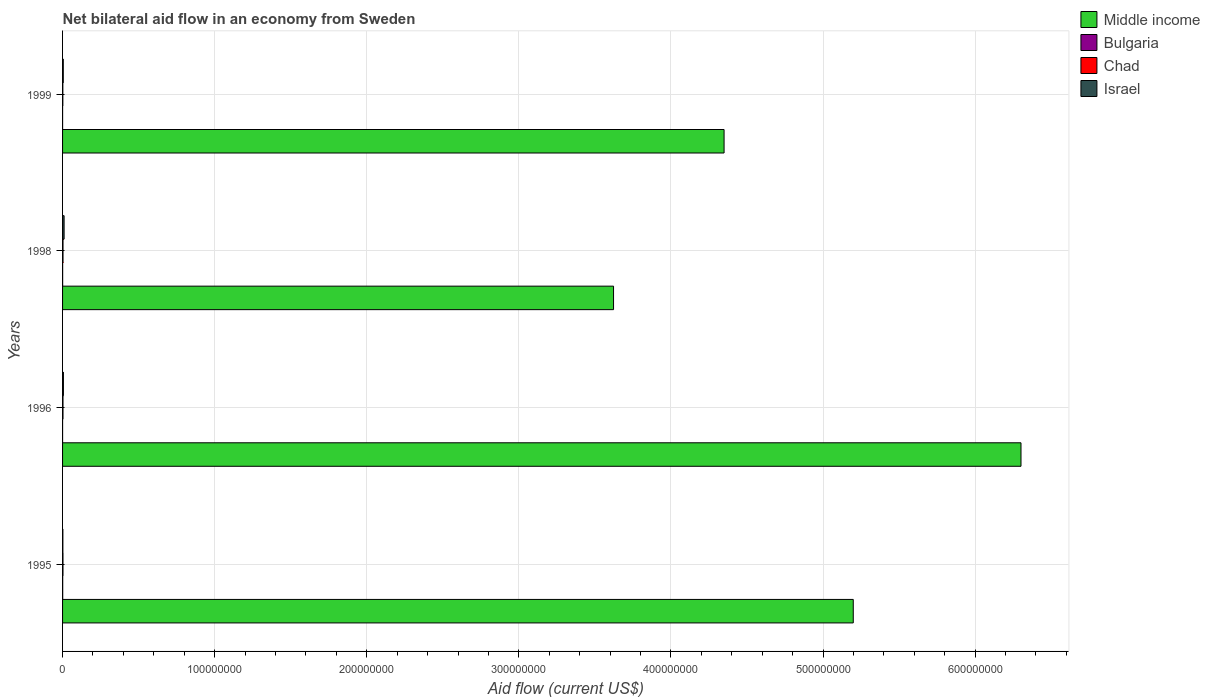How many different coloured bars are there?
Provide a short and direct response. 4. How many groups of bars are there?
Offer a terse response. 4. Are the number of bars per tick equal to the number of legend labels?
Your response must be concise. Yes. How many bars are there on the 3rd tick from the top?
Offer a terse response. 4. How many bars are there on the 3rd tick from the bottom?
Make the answer very short. 4. What is the label of the 4th group of bars from the top?
Your answer should be compact. 1995. What is the net bilateral aid flow in Chad in 1999?
Give a very brief answer. 1.80e+05. Across all years, what is the maximum net bilateral aid flow in Middle income?
Ensure brevity in your answer.  6.30e+08. In which year was the net bilateral aid flow in Middle income maximum?
Your answer should be compact. 1996. What is the total net bilateral aid flow in Chad in the graph?
Ensure brevity in your answer.  1.04e+06. What is the difference between the net bilateral aid flow in Middle income in 1995 and that in 1999?
Give a very brief answer. 8.49e+07. What is the difference between the net bilateral aid flow in Middle income in 1996 and the net bilateral aid flow in Israel in 1998?
Ensure brevity in your answer.  6.29e+08. What is the average net bilateral aid flow in Israel per year?
Make the answer very short. 5.60e+05. In how many years, is the net bilateral aid flow in Middle income greater than 100000000 US$?
Give a very brief answer. 4. What is the ratio of the net bilateral aid flow in Chad in 1996 to that in 1999?
Provide a short and direct response. 1.61. Is the net bilateral aid flow in Bulgaria in 1995 less than that in 1999?
Keep it short and to the point. No. In how many years, is the net bilateral aid flow in Bulgaria greater than the average net bilateral aid flow in Bulgaria taken over all years?
Give a very brief answer. 2. Is the sum of the net bilateral aid flow in Chad in 1995 and 1998 greater than the maximum net bilateral aid flow in Middle income across all years?
Your response must be concise. No. Is it the case that in every year, the sum of the net bilateral aid flow in Bulgaria and net bilateral aid flow in Israel is greater than the sum of net bilateral aid flow in Chad and net bilateral aid flow in Middle income?
Ensure brevity in your answer.  No. What does the 3rd bar from the bottom in 1995 represents?
Your response must be concise. Chad. How many bars are there?
Your answer should be very brief. 16. Are all the bars in the graph horizontal?
Your answer should be very brief. Yes. How many years are there in the graph?
Give a very brief answer. 4. What is the difference between two consecutive major ticks on the X-axis?
Keep it short and to the point. 1.00e+08. Does the graph contain any zero values?
Your answer should be compact. No. Does the graph contain grids?
Provide a succinct answer. Yes. Where does the legend appear in the graph?
Give a very brief answer. Top right. What is the title of the graph?
Give a very brief answer. Net bilateral aid flow in an economy from Sweden. Does "Yemen, Rep." appear as one of the legend labels in the graph?
Provide a succinct answer. No. What is the label or title of the Y-axis?
Provide a short and direct response. Years. What is the Aid flow (current US$) in Middle income in 1995?
Offer a terse response. 5.20e+08. What is the Aid flow (current US$) in Chad in 1995?
Offer a terse response. 2.70e+05. What is the Aid flow (current US$) in Israel in 1995?
Keep it short and to the point. 2.00e+05. What is the Aid flow (current US$) of Middle income in 1996?
Your answer should be compact. 6.30e+08. What is the Aid flow (current US$) of Bulgaria in 1996?
Your answer should be compact. 10000. What is the Aid flow (current US$) in Israel in 1996?
Keep it short and to the point. 5.60e+05. What is the Aid flow (current US$) of Middle income in 1998?
Provide a succinct answer. 3.62e+08. What is the Aid flow (current US$) in Chad in 1998?
Your response must be concise. 3.00e+05. What is the Aid flow (current US$) of Israel in 1998?
Your answer should be compact. 1.01e+06. What is the Aid flow (current US$) of Middle income in 1999?
Your answer should be compact. 4.35e+08. What is the Aid flow (current US$) of Israel in 1999?
Offer a terse response. 4.70e+05. Across all years, what is the maximum Aid flow (current US$) of Middle income?
Your response must be concise. 6.30e+08. Across all years, what is the maximum Aid flow (current US$) in Israel?
Ensure brevity in your answer.  1.01e+06. Across all years, what is the minimum Aid flow (current US$) of Middle income?
Provide a short and direct response. 3.62e+08. Across all years, what is the minimum Aid flow (current US$) in Chad?
Make the answer very short. 1.80e+05. What is the total Aid flow (current US$) in Middle income in the graph?
Provide a short and direct response. 1.95e+09. What is the total Aid flow (current US$) in Chad in the graph?
Offer a terse response. 1.04e+06. What is the total Aid flow (current US$) in Israel in the graph?
Offer a terse response. 2.24e+06. What is the difference between the Aid flow (current US$) in Middle income in 1995 and that in 1996?
Give a very brief answer. -1.10e+08. What is the difference between the Aid flow (current US$) in Israel in 1995 and that in 1996?
Provide a short and direct response. -3.60e+05. What is the difference between the Aid flow (current US$) of Middle income in 1995 and that in 1998?
Your response must be concise. 1.58e+08. What is the difference between the Aid flow (current US$) of Chad in 1995 and that in 1998?
Offer a terse response. -3.00e+04. What is the difference between the Aid flow (current US$) in Israel in 1995 and that in 1998?
Your answer should be very brief. -8.10e+05. What is the difference between the Aid flow (current US$) of Middle income in 1995 and that in 1999?
Your answer should be compact. 8.49e+07. What is the difference between the Aid flow (current US$) in Bulgaria in 1995 and that in 1999?
Offer a very short reply. 7.00e+04. What is the difference between the Aid flow (current US$) in Chad in 1995 and that in 1999?
Your response must be concise. 9.00e+04. What is the difference between the Aid flow (current US$) of Middle income in 1996 and that in 1998?
Your answer should be compact. 2.68e+08. What is the difference between the Aid flow (current US$) of Bulgaria in 1996 and that in 1998?
Make the answer very short. -4.00e+04. What is the difference between the Aid flow (current US$) of Chad in 1996 and that in 1998?
Make the answer very short. -10000. What is the difference between the Aid flow (current US$) in Israel in 1996 and that in 1998?
Ensure brevity in your answer.  -4.50e+05. What is the difference between the Aid flow (current US$) in Middle income in 1996 and that in 1999?
Provide a short and direct response. 1.95e+08. What is the difference between the Aid flow (current US$) in Bulgaria in 1996 and that in 1999?
Provide a short and direct response. -10000. What is the difference between the Aid flow (current US$) of Chad in 1996 and that in 1999?
Keep it short and to the point. 1.10e+05. What is the difference between the Aid flow (current US$) of Israel in 1996 and that in 1999?
Offer a terse response. 9.00e+04. What is the difference between the Aid flow (current US$) of Middle income in 1998 and that in 1999?
Give a very brief answer. -7.27e+07. What is the difference between the Aid flow (current US$) of Chad in 1998 and that in 1999?
Give a very brief answer. 1.20e+05. What is the difference between the Aid flow (current US$) in Israel in 1998 and that in 1999?
Keep it short and to the point. 5.40e+05. What is the difference between the Aid flow (current US$) in Middle income in 1995 and the Aid flow (current US$) in Bulgaria in 1996?
Your response must be concise. 5.20e+08. What is the difference between the Aid flow (current US$) of Middle income in 1995 and the Aid flow (current US$) of Chad in 1996?
Offer a terse response. 5.20e+08. What is the difference between the Aid flow (current US$) of Middle income in 1995 and the Aid flow (current US$) of Israel in 1996?
Give a very brief answer. 5.19e+08. What is the difference between the Aid flow (current US$) of Bulgaria in 1995 and the Aid flow (current US$) of Israel in 1996?
Provide a short and direct response. -4.70e+05. What is the difference between the Aid flow (current US$) of Chad in 1995 and the Aid flow (current US$) of Israel in 1996?
Make the answer very short. -2.90e+05. What is the difference between the Aid flow (current US$) in Middle income in 1995 and the Aid flow (current US$) in Bulgaria in 1998?
Your answer should be very brief. 5.20e+08. What is the difference between the Aid flow (current US$) of Middle income in 1995 and the Aid flow (current US$) of Chad in 1998?
Keep it short and to the point. 5.20e+08. What is the difference between the Aid flow (current US$) in Middle income in 1995 and the Aid flow (current US$) in Israel in 1998?
Offer a terse response. 5.19e+08. What is the difference between the Aid flow (current US$) of Bulgaria in 1995 and the Aid flow (current US$) of Israel in 1998?
Offer a very short reply. -9.20e+05. What is the difference between the Aid flow (current US$) in Chad in 1995 and the Aid flow (current US$) in Israel in 1998?
Keep it short and to the point. -7.40e+05. What is the difference between the Aid flow (current US$) in Middle income in 1995 and the Aid flow (current US$) in Bulgaria in 1999?
Your response must be concise. 5.20e+08. What is the difference between the Aid flow (current US$) of Middle income in 1995 and the Aid flow (current US$) of Chad in 1999?
Offer a very short reply. 5.20e+08. What is the difference between the Aid flow (current US$) in Middle income in 1995 and the Aid flow (current US$) in Israel in 1999?
Your response must be concise. 5.19e+08. What is the difference between the Aid flow (current US$) in Bulgaria in 1995 and the Aid flow (current US$) in Israel in 1999?
Ensure brevity in your answer.  -3.80e+05. What is the difference between the Aid flow (current US$) in Middle income in 1996 and the Aid flow (current US$) in Bulgaria in 1998?
Make the answer very short. 6.30e+08. What is the difference between the Aid flow (current US$) in Middle income in 1996 and the Aid flow (current US$) in Chad in 1998?
Your answer should be very brief. 6.30e+08. What is the difference between the Aid flow (current US$) of Middle income in 1996 and the Aid flow (current US$) of Israel in 1998?
Ensure brevity in your answer.  6.29e+08. What is the difference between the Aid flow (current US$) of Bulgaria in 1996 and the Aid flow (current US$) of Chad in 1998?
Provide a succinct answer. -2.90e+05. What is the difference between the Aid flow (current US$) in Chad in 1996 and the Aid flow (current US$) in Israel in 1998?
Give a very brief answer. -7.20e+05. What is the difference between the Aid flow (current US$) of Middle income in 1996 and the Aid flow (current US$) of Bulgaria in 1999?
Your answer should be very brief. 6.30e+08. What is the difference between the Aid flow (current US$) of Middle income in 1996 and the Aid flow (current US$) of Chad in 1999?
Give a very brief answer. 6.30e+08. What is the difference between the Aid flow (current US$) in Middle income in 1996 and the Aid flow (current US$) in Israel in 1999?
Offer a very short reply. 6.30e+08. What is the difference between the Aid flow (current US$) in Bulgaria in 1996 and the Aid flow (current US$) in Chad in 1999?
Your answer should be very brief. -1.70e+05. What is the difference between the Aid flow (current US$) in Bulgaria in 1996 and the Aid flow (current US$) in Israel in 1999?
Ensure brevity in your answer.  -4.60e+05. What is the difference between the Aid flow (current US$) in Middle income in 1998 and the Aid flow (current US$) in Bulgaria in 1999?
Provide a succinct answer. 3.62e+08. What is the difference between the Aid flow (current US$) in Middle income in 1998 and the Aid flow (current US$) in Chad in 1999?
Provide a succinct answer. 3.62e+08. What is the difference between the Aid flow (current US$) in Middle income in 1998 and the Aid flow (current US$) in Israel in 1999?
Your answer should be very brief. 3.62e+08. What is the difference between the Aid flow (current US$) in Bulgaria in 1998 and the Aid flow (current US$) in Chad in 1999?
Offer a very short reply. -1.30e+05. What is the difference between the Aid flow (current US$) in Bulgaria in 1998 and the Aid flow (current US$) in Israel in 1999?
Your answer should be compact. -4.20e+05. What is the average Aid flow (current US$) of Middle income per year?
Ensure brevity in your answer.  4.87e+08. What is the average Aid flow (current US$) of Bulgaria per year?
Offer a very short reply. 4.25e+04. What is the average Aid flow (current US$) of Chad per year?
Offer a very short reply. 2.60e+05. What is the average Aid flow (current US$) in Israel per year?
Keep it short and to the point. 5.60e+05. In the year 1995, what is the difference between the Aid flow (current US$) of Middle income and Aid flow (current US$) of Bulgaria?
Ensure brevity in your answer.  5.20e+08. In the year 1995, what is the difference between the Aid flow (current US$) in Middle income and Aid flow (current US$) in Chad?
Your answer should be compact. 5.20e+08. In the year 1995, what is the difference between the Aid flow (current US$) in Middle income and Aid flow (current US$) in Israel?
Provide a short and direct response. 5.20e+08. In the year 1995, what is the difference between the Aid flow (current US$) in Bulgaria and Aid flow (current US$) in Chad?
Your answer should be compact. -1.80e+05. In the year 1995, what is the difference between the Aid flow (current US$) of Chad and Aid flow (current US$) of Israel?
Your answer should be compact. 7.00e+04. In the year 1996, what is the difference between the Aid flow (current US$) of Middle income and Aid flow (current US$) of Bulgaria?
Give a very brief answer. 6.30e+08. In the year 1996, what is the difference between the Aid flow (current US$) of Middle income and Aid flow (current US$) of Chad?
Your response must be concise. 6.30e+08. In the year 1996, what is the difference between the Aid flow (current US$) in Middle income and Aid flow (current US$) in Israel?
Your response must be concise. 6.30e+08. In the year 1996, what is the difference between the Aid flow (current US$) in Bulgaria and Aid flow (current US$) in Chad?
Ensure brevity in your answer.  -2.80e+05. In the year 1996, what is the difference between the Aid flow (current US$) of Bulgaria and Aid flow (current US$) of Israel?
Your response must be concise. -5.50e+05. In the year 1996, what is the difference between the Aid flow (current US$) in Chad and Aid flow (current US$) in Israel?
Make the answer very short. -2.70e+05. In the year 1998, what is the difference between the Aid flow (current US$) of Middle income and Aid flow (current US$) of Bulgaria?
Offer a very short reply. 3.62e+08. In the year 1998, what is the difference between the Aid flow (current US$) in Middle income and Aid flow (current US$) in Chad?
Provide a succinct answer. 3.62e+08. In the year 1998, what is the difference between the Aid flow (current US$) of Middle income and Aid flow (current US$) of Israel?
Keep it short and to the point. 3.61e+08. In the year 1998, what is the difference between the Aid flow (current US$) in Bulgaria and Aid flow (current US$) in Israel?
Offer a very short reply. -9.60e+05. In the year 1998, what is the difference between the Aid flow (current US$) of Chad and Aid flow (current US$) of Israel?
Provide a succinct answer. -7.10e+05. In the year 1999, what is the difference between the Aid flow (current US$) in Middle income and Aid flow (current US$) in Bulgaria?
Provide a short and direct response. 4.35e+08. In the year 1999, what is the difference between the Aid flow (current US$) in Middle income and Aid flow (current US$) in Chad?
Your answer should be compact. 4.35e+08. In the year 1999, what is the difference between the Aid flow (current US$) of Middle income and Aid flow (current US$) of Israel?
Provide a short and direct response. 4.34e+08. In the year 1999, what is the difference between the Aid flow (current US$) of Bulgaria and Aid flow (current US$) of Chad?
Make the answer very short. -1.60e+05. In the year 1999, what is the difference between the Aid flow (current US$) of Bulgaria and Aid flow (current US$) of Israel?
Your answer should be very brief. -4.50e+05. In the year 1999, what is the difference between the Aid flow (current US$) of Chad and Aid flow (current US$) of Israel?
Ensure brevity in your answer.  -2.90e+05. What is the ratio of the Aid flow (current US$) in Middle income in 1995 to that in 1996?
Provide a short and direct response. 0.82. What is the ratio of the Aid flow (current US$) in Bulgaria in 1995 to that in 1996?
Keep it short and to the point. 9. What is the ratio of the Aid flow (current US$) of Israel in 1995 to that in 1996?
Keep it short and to the point. 0.36. What is the ratio of the Aid flow (current US$) of Middle income in 1995 to that in 1998?
Offer a terse response. 1.44. What is the ratio of the Aid flow (current US$) in Israel in 1995 to that in 1998?
Ensure brevity in your answer.  0.2. What is the ratio of the Aid flow (current US$) of Middle income in 1995 to that in 1999?
Your response must be concise. 1.2. What is the ratio of the Aid flow (current US$) in Bulgaria in 1995 to that in 1999?
Make the answer very short. 4.5. What is the ratio of the Aid flow (current US$) in Chad in 1995 to that in 1999?
Your answer should be very brief. 1.5. What is the ratio of the Aid flow (current US$) in Israel in 1995 to that in 1999?
Your answer should be very brief. 0.43. What is the ratio of the Aid flow (current US$) in Middle income in 1996 to that in 1998?
Provide a succinct answer. 1.74. What is the ratio of the Aid flow (current US$) of Bulgaria in 1996 to that in 1998?
Make the answer very short. 0.2. What is the ratio of the Aid flow (current US$) in Chad in 1996 to that in 1998?
Ensure brevity in your answer.  0.97. What is the ratio of the Aid flow (current US$) in Israel in 1996 to that in 1998?
Give a very brief answer. 0.55. What is the ratio of the Aid flow (current US$) of Middle income in 1996 to that in 1999?
Provide a succinct answer. 1.45. What is the ratio of the Aid flow (current US$) of Chad in 1996 to that in 1999?
Ensure brevity in your answer.  1.61. What is the ratio of the Aid flow (current US$) in Israel in 1996 to that in 1999?
Your answer should be very brief. 1.19. What is the ratio of the Aid flow (current US$) in Middle income in 1998 to that in 1999?
Offer a terse response. 0.83. What is the ratio of the Aid flow (current US$) in Chad in 1998 to that in 1999?
Give a very brief answer. 1.67. What is the ratio of the Aid flow (current US$) of Israel in 1998 to that in 1999?
Give a very brief answer. 2.15. What is the difference between the highest and the second highest Aid flow (current US$) of Middle income?
Provide a short and direct response. 1.10e+08. What is the difference between the highest and the second highest Aid flow (current US$) of Bulgaria?
Provide a succinct answer. 4.00e+04. What is the difference between the highest and the second highest Aid flow (current US$) in Israel?
Your response must be concise. 4.50e+05. What is the difference between the highest and the lowest Aid flow (current US$) of Middle income?
Offer a terse response. 2.68e+08. What is the difference between the highest and the lowest Aid flow (current US$) of Chad?
Give a very brief answer. 1.20e+05. What is the difference between the highest and the lowest Aid flow (current US$) in Israel?
Offer a terse response. 8.10e+05. 